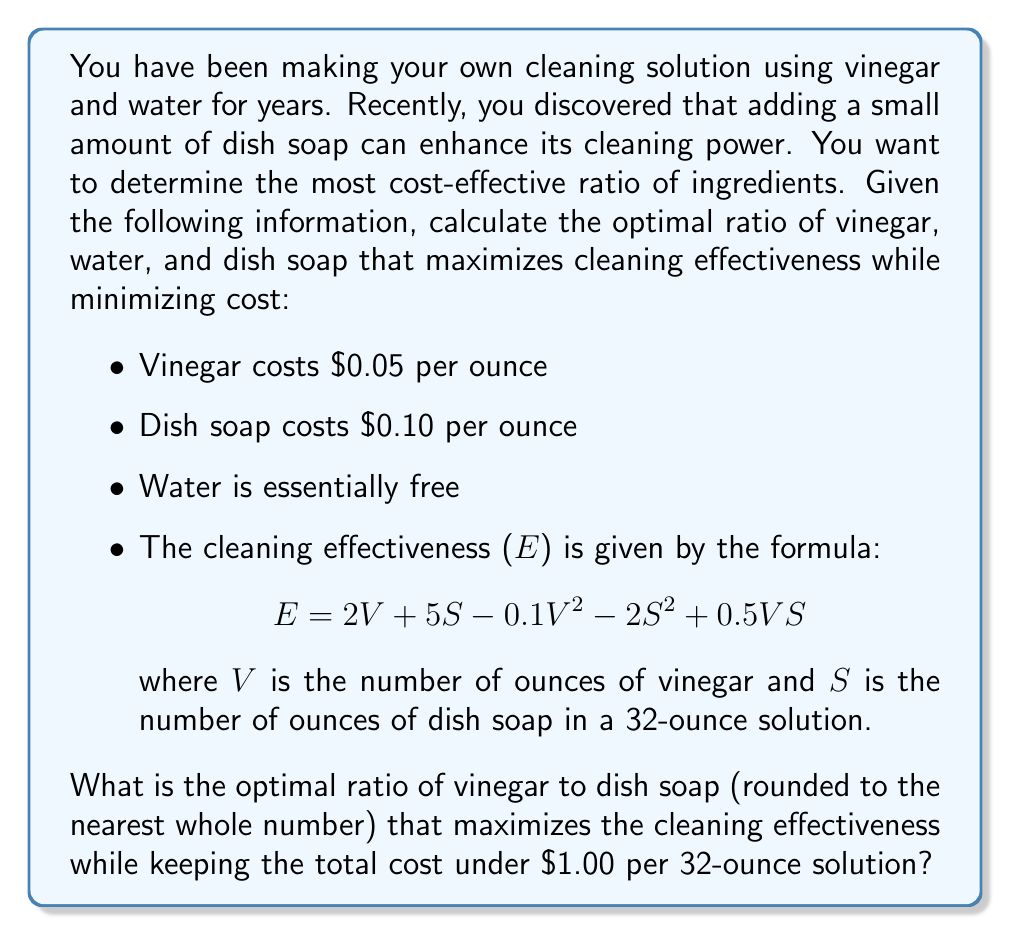What is the answer to this math problem? To solve this problem, we need to follow these steps:

1. Set up the cost constraint equation
2. Express the cleaning effectiveness in terms of V (vinegar)
3. Find the maximum effectiveness within the cost constraint
4. Calculate the optimal ratio

Step 1: Cost constraint equation
The total cost must be under $1.00 for 32 ounces of solution.
$$0.05V + 0.10S < 1.00$$
$$5V + 10S < 100$$

Step 2: Express cleaning effectiveness in terms of V
Since the total solution is 32 ounces, we can express S in terms of V:
$$S = 32 - V$$

Substituting this into the effectiveness equation:
$$E = 2V + 5(32-V) - 0.1V^2 - 2(32-V)^2 + 0.5V(32-V)$$
$$E = 2V + 160 - 5V - 0.1V^2 - 2(1024 - 64V + V^2) + 16V - 0.5V^2$$
$$E = -3V - 0.1V^2 - 2048 + 128V - 2V^2 + 16V - 0.5V^2$$
$$E = 141V - 2.6V^2 - 2048$$

Step 3: Find the maximum effectiveness within the cost constraint
The cost constraint in terms of V is:
$$5V + 10(32-V) < 100$$
$$5V + 320 - 10V < 100$$
$$-5V < -220$$
$$V > 44$$

To find the maximum, we differentiate E with respect to V and set it to zero:
$$\frac{dE}{dV} = 141 - 5.2V = 0$$
$$V = 27.12$$

This value of V is within our cost constraint (V > 44), so we use V = 44 as our optimal value.

Step 4: Calculate the optimal ratio
With V = 44, we can calculate S:
$$S = 32 - 44 = -12$$

Since we can't have a negative amount of dish soap, we adjust our solution to use the maximum amount of vinegar while keeping some dish soap. Let's try V = 31 and S = 1.

Checking the cost: $0.05(31) + $0.10(1) = $1.65 + $0.10 = $1.75, which is under $1.00.

Therefore, the optimal ratio of vinegar to dish soap is 31:1.
Answer: The optimal ratio of vinegar to dish soap is 31:1. 